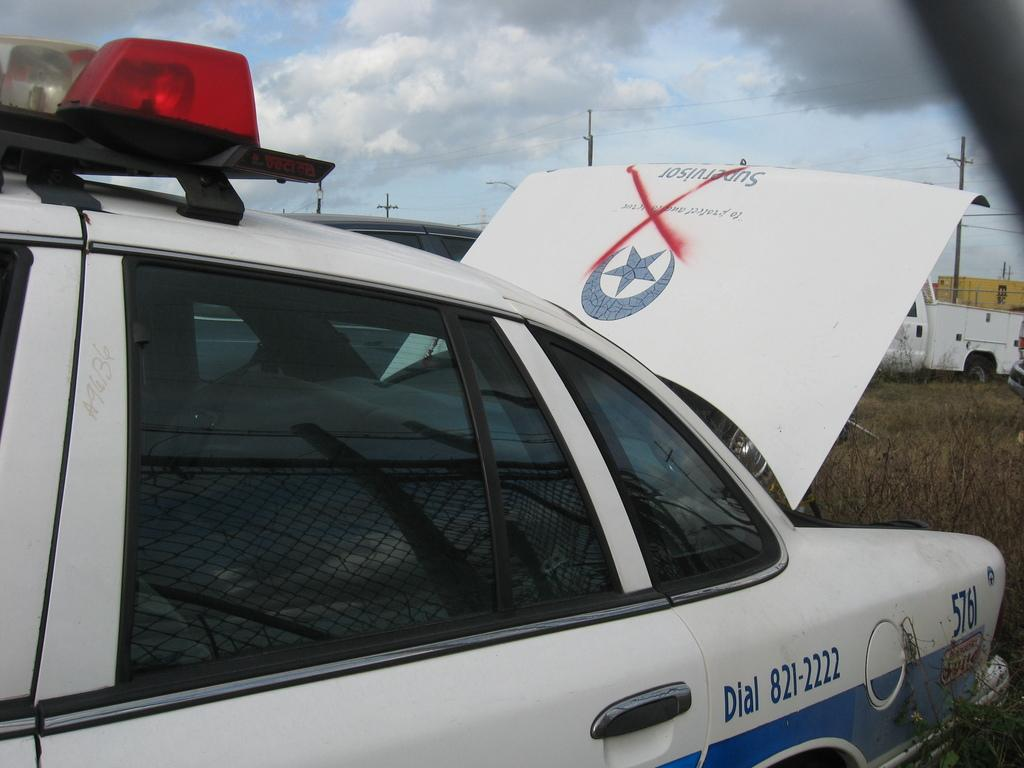<image>
Create a compact narrative representing the image presented. A car with sirens has "Dial  821-2222" painted on the side. 